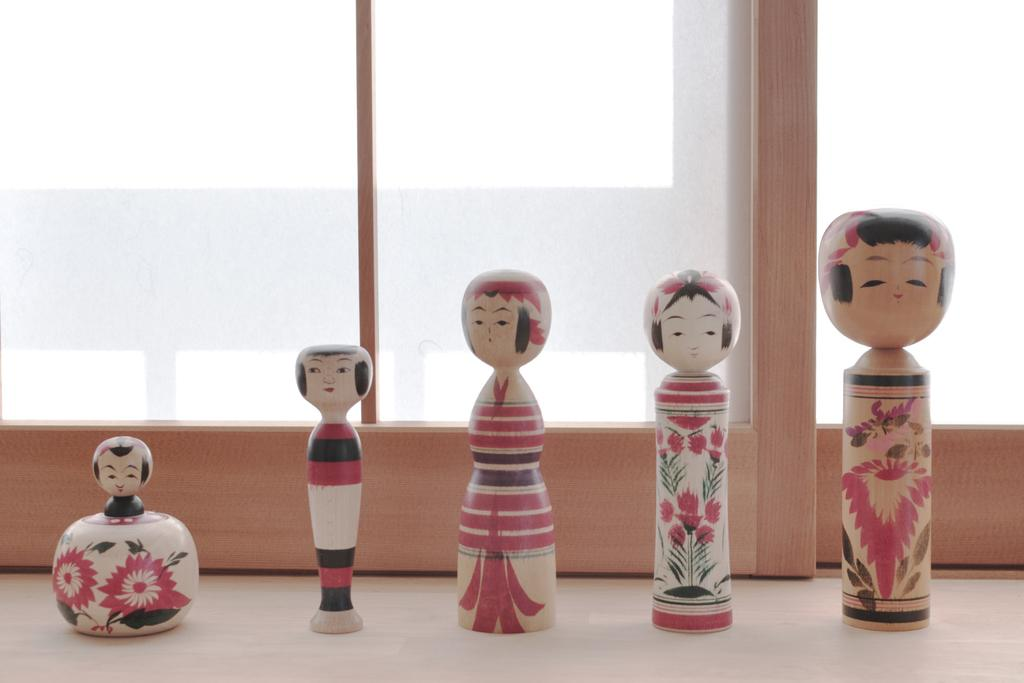What type of dolls are present in the image? There are wooden dolls on a surface in the image. Can you describe the background of the image? The background of the image includes glass. What type of fruit is being used as a veil for the dolls in the image? There is no fruit or veil present in the image; it features wooden dolls on a surface with a glass background. 